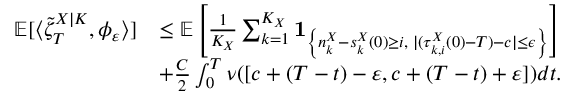Convert formula to latex. <formula><loc_0><loc_0><loc_500><loc_500>\begin{array} { r l } { \mathbb { E } [ \langle \tilde { \zeta } _ { T } ^ { X | K } , \phi _ { \varepsilon } \rangle ] } & { \leq \mathbb { E } \left [ \frac { 1 } { K _ { X } } \sum _ { k = 1 } ^ { K _ { X } } 1 _ { \left \{ n _ { k } ^ { X } - s _ { k } ^ { X } ( 0 ) \geq i , \, | ( \tau _ { k , i } ^ { X } ( 0 ) - T ) - c | \leq \epsilon \right \} } \right ] } \\ & { + \frac { C } { 2 } \int _ { 0 } ^ { T } \nu ( [ c + ( T - t ) - \varepsilon , c + ( T - t ) + \varepsilon ] ) d t . } \end{array}</formula> 